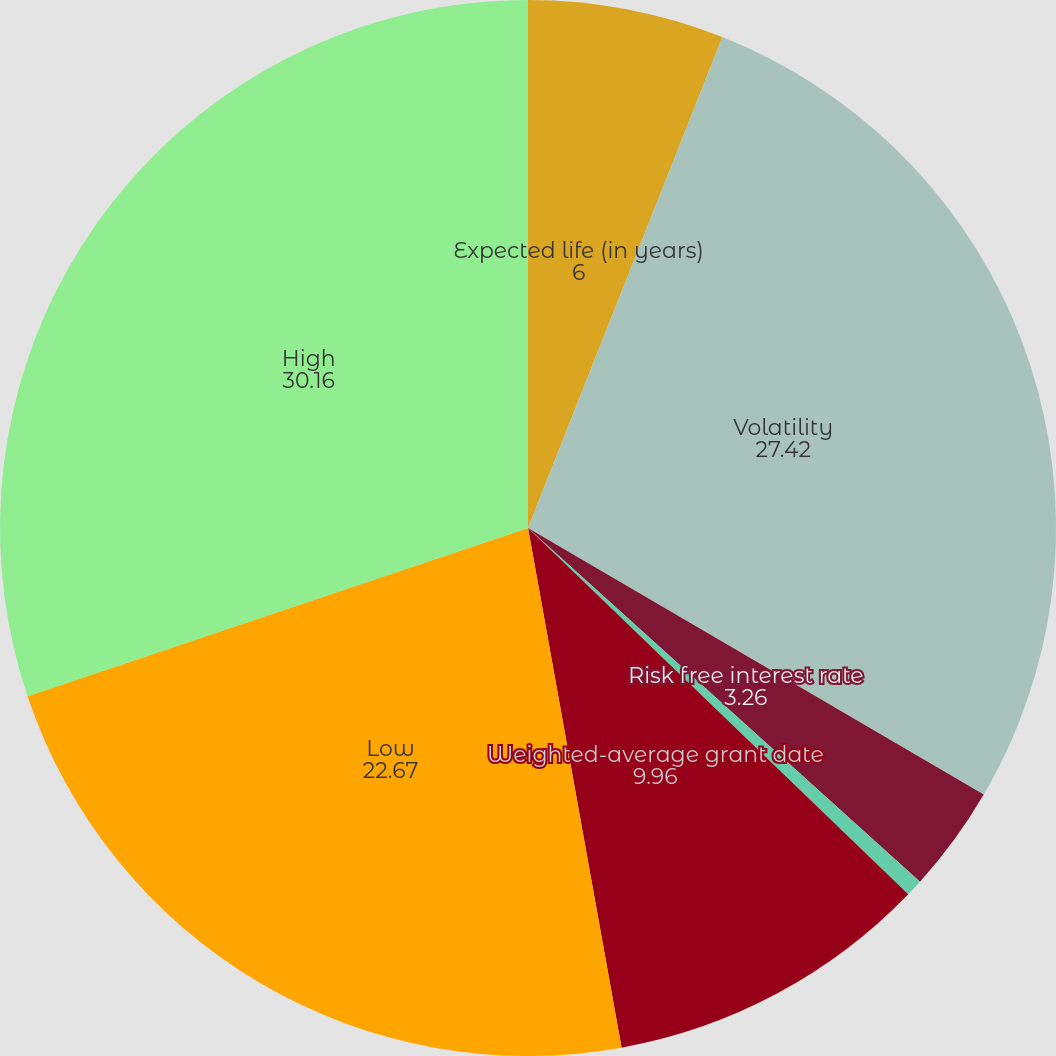Convert chart. <chart><loc_0><loc_0><loc_500><loc_500><pie_chart><fcel>Expected life (in years)<fcel>Volatility<fcel>Risk free interest rate<fcel>Dividend yield<fcel>Weighted-average grant date<fcel>Low<fcel>High<nl><fcel>6.0%<fcel>27.42%<fcel>3.26%<fcel>0.52%<fcel>9.96%<fcel>22.67%<fcel>30.16%<nl></chart> 